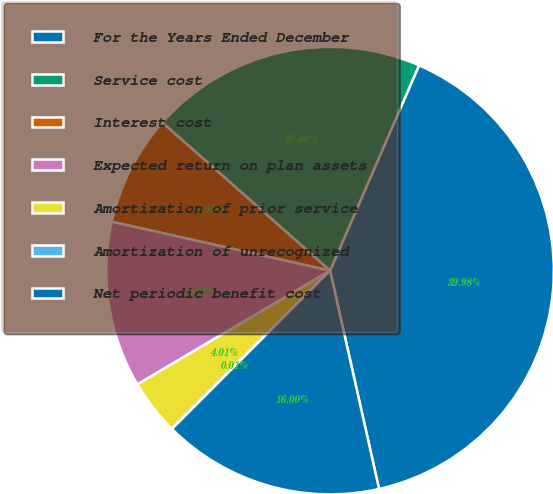Convert chart to OTSL. <chart><loc_0><loc_0><loc_500><loc_500><pie_chart><fcel>For the Years Ended December<fcel>Service cost<fcel>Interest cost<fcel>Expected return on plan assets<fcel>Amortization of prior service<fcel>Amortization of unrecognized<fcel>Net periodic benefit cost<nl><fcel>39.98%<fcel>20.0%<fcel>8.0%<fcel>12.0%<fcel>4.01%<fcel>0.01%<fcel>16.0%<nl></chart> 